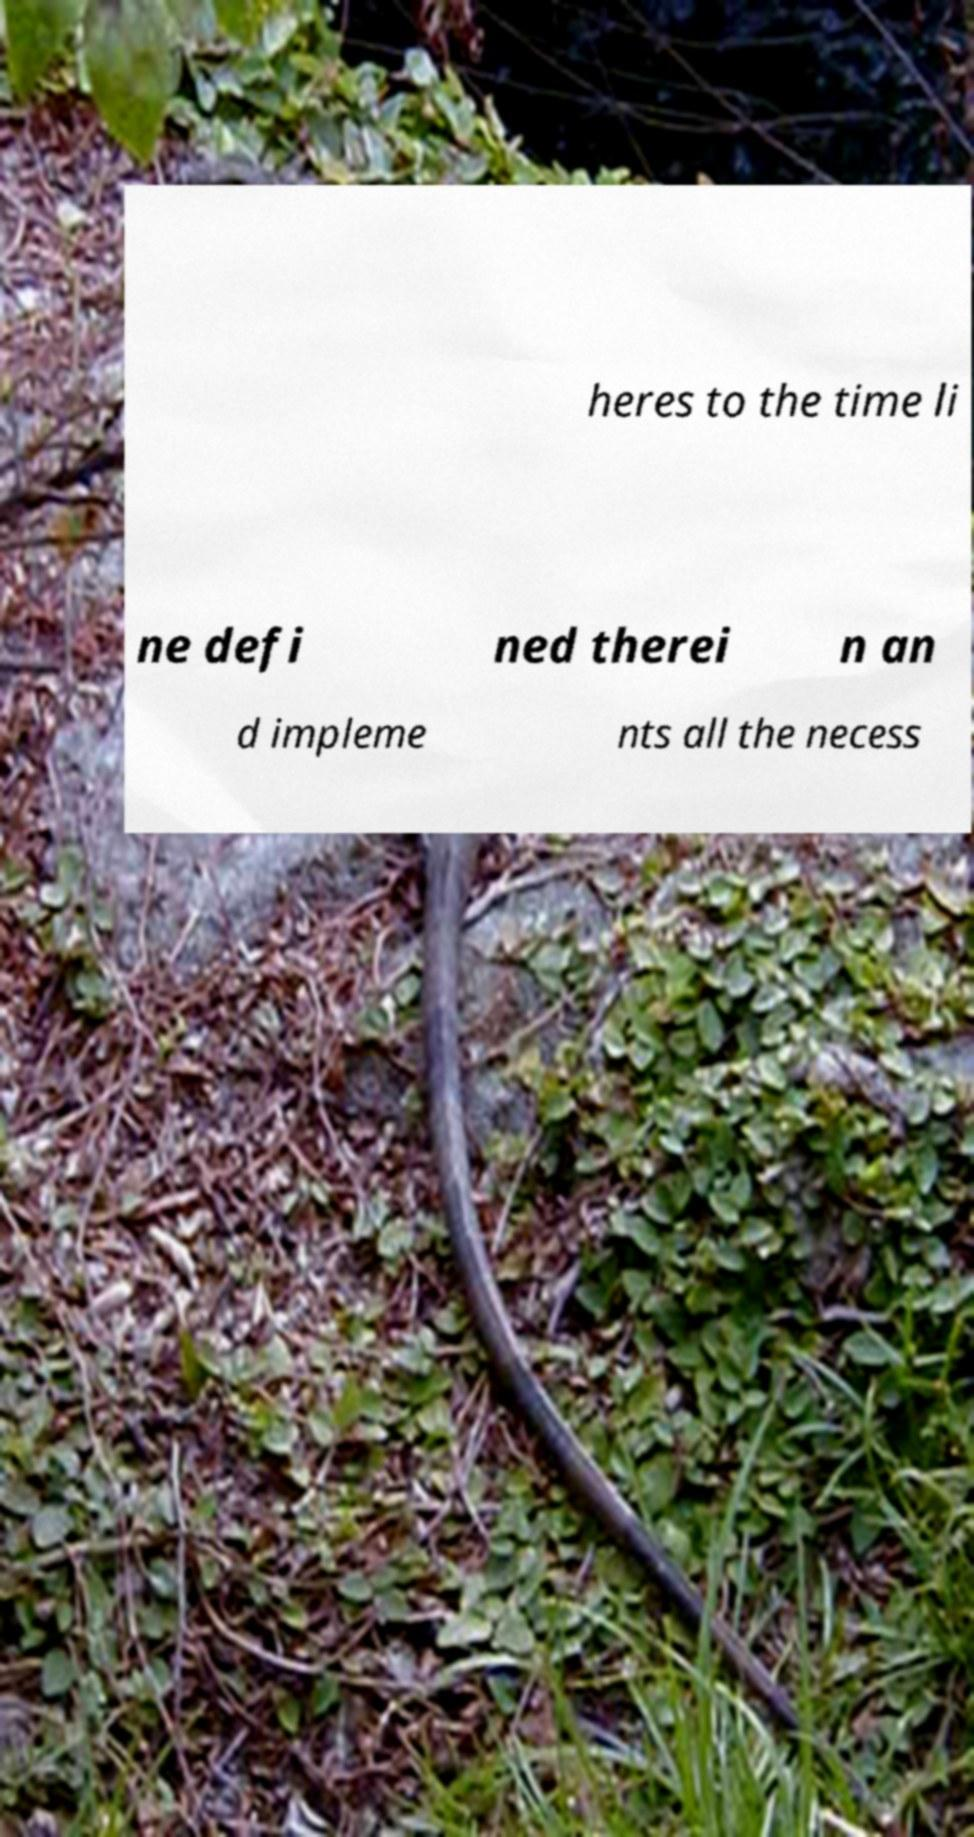What messages or text are displayed in this image? I need them in a readable, typed format. heres to the time li ne defi ned therei n an d impleme nts all the necess 